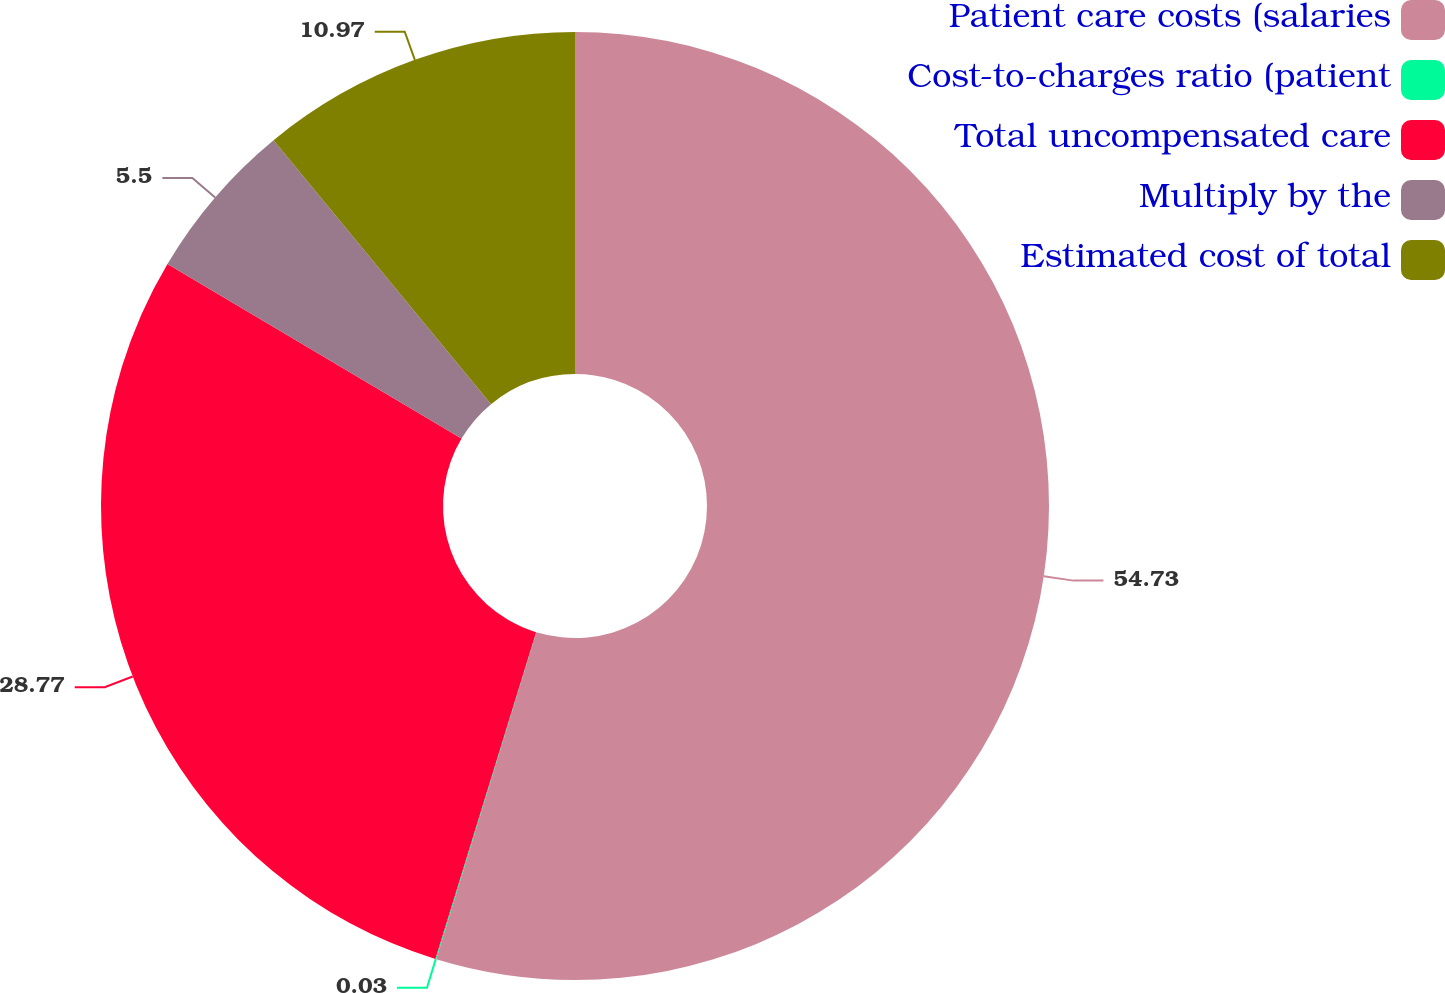Convert chart to OTSL. <chart><loc_0><loc_0><loc_500><loc_500><pie_chart><fcel>Patient care costs (salaries<fcel>Cost-to-charges ratio (patient<fcel>Total uncompensated care<fcel>Multiply by the<fcel>Estimated cost of total<nl><fcel>54.73%<fcel>0.03%<fcel>28.77%<fcel>5.5%<fcel>10.97%<nl></chart> 